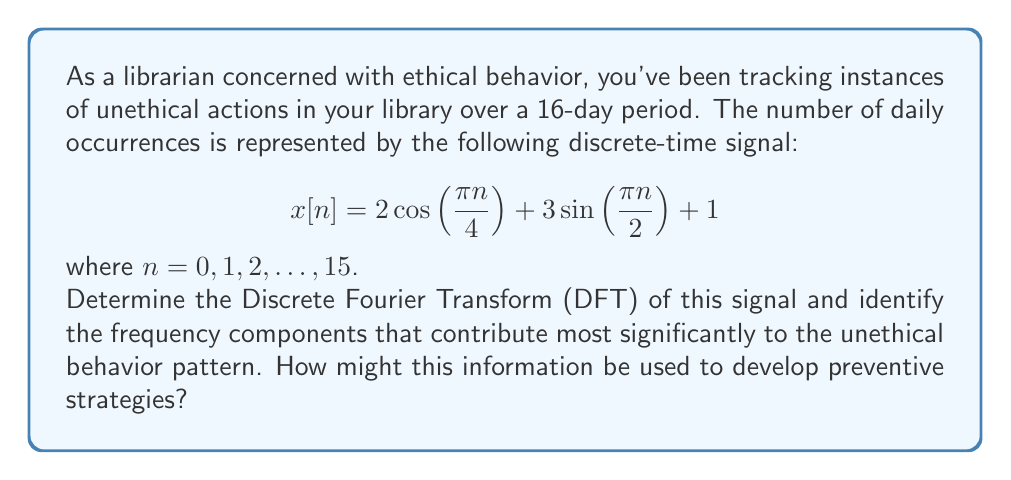Show me your answer to this math problem. To solve this problem, we'll follow these steps:

1) First, recall the formula for the N-point DFT:

   $X[k] = \sum_{n=0}^{N-1} x[n] e^{-j2\pi kn/N}$

   where $N = 16$ in this case.

2) Our signal $x[n]$ consists of three components:
   
   $2 \cos(\frac{\pi n}{4})$, $3 \sin(\frac{\pi n}{2})$, and a constant term 1.

3) We can use the following properties of the DFT:

   - DFT of $\cos(\frac{2\pi k_0 n}{N}) = \frac{N}{2}(\delta[k-k_0] + \delta[k-(N-k_0)])$
   - DFT of $\sin(\frac{2\pi k_0 n}{N}) = \frac{N}{2j}(\delta[k-k_0] - \delta[k-(N-k_0)])$
   - DFT of a constant $c$ is $cN\delta[k]$

4) For the cosine term: $2 \cos(\frac{\pi n}{4}) = 2 \cos(\frac{2\pi 2n}{16})$
   Its DFT will have peaks at $k = 2$ and $k = 14$:
   
   $16(\delta[k-2] + \delta[k-14])$

5) For the sine term: $3 \sin(\frac{\pi n}{2}) = 3 \sin(\frac{2\pi 4n}{16})$
   Its DFT will have peaks at $k = 4$ and $k = 12$:
   
   $\frac{24j}{2}(\delta[k-4] - \delta[k-12]) = 12j(\delta[k-4] - \delta[k-12])$

6) The constant term 1 will contribute $16\delta[k]$ to the DFT.

7) Combining these results, we get:

   $X[k] = 16\delta[k] + 16(\delta[k-2] + \delta[k-14]) + 12j(\delta[k-4] - \delta[k-12])$

8) The magnitude spectrum will be:

   $|X[k]| = \begin{cases}
   16 & \text{if } k = 0 \\
   16 & \text{if } k = 2 \text{ or } 14 \\
   12 & \text{if } k = 4 \text{ or } 12 \\
   0 & \text{otherwise}
   \end{cases}$

9) The most significant frequency components are at $k = 0$ (DC component), $k = 2$ (and its symmetric counterpart at $k = 14$), and $k = 4$ (and its counterpart at $k = 12$).

This analysis reveals that the unethical behavior pattern has strong periodic components at frequencies corresponding to 2 and 4 cycles over the 16-day period (i.e., 8-day and 4-day cycles). The librarian could use this information to develop preventive strategies that focus on these specific time intervals, perhaps by increasing vigilance or implementing additional safeguards during these cyclical peaks of unethical behavior.
Answer: The DFT of the signal is:

$X[k] = 16\delta[k] + 16(\delta[k-2] + \delta[k-14]) + 12j(\delta[k-4] - \delta[k-12])$

The most significant frequency components are at $k = 0$, $k = 2$ (and $k = 14$), and $k = 4$ (and $k = 12$), corresponding to DC, 8-day cycles, and 4-day cycles respectively. Preventive strategies should focus on these cyclical patterns of unethical behavior. 